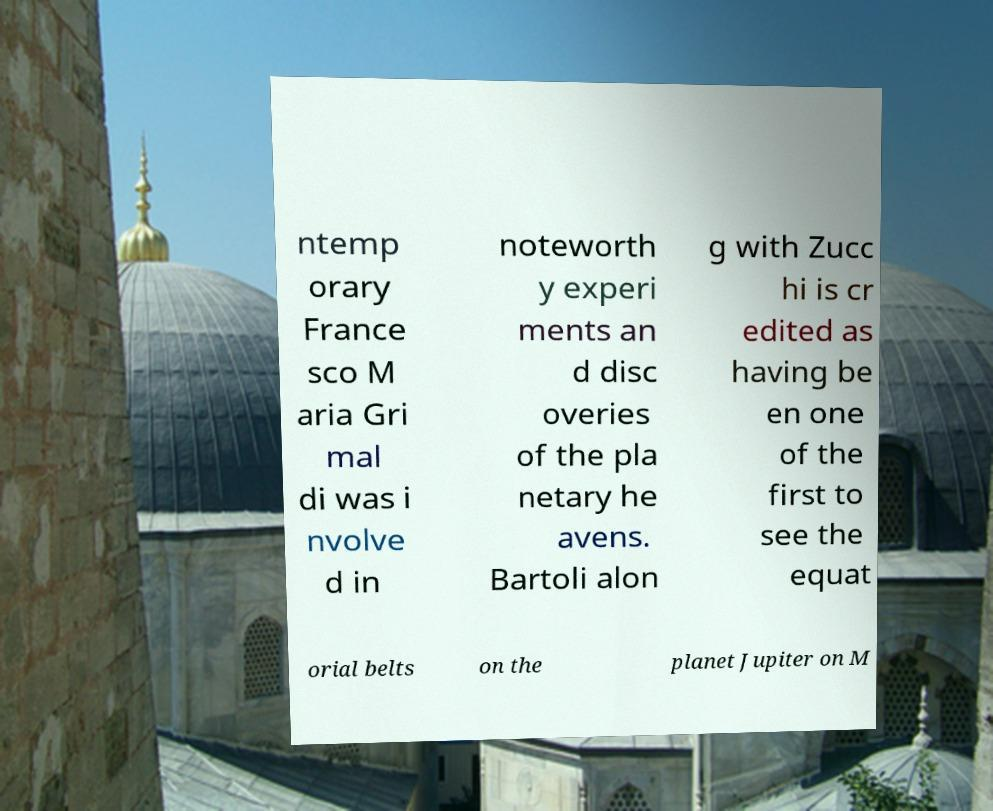Can you read and provide the text displayed in the image?This photo seems to have some interesting text. Can you extract and type it out for me? ntemp orary France sco M aria Gri mal di was i nvolve d in noteworth y experi ments an d disc overies of the pla netary he avens. Bartoli alon g with Zucc hi is cr edited as having be en one of the first to see the equat orial belts on the planet Jupiter on M 